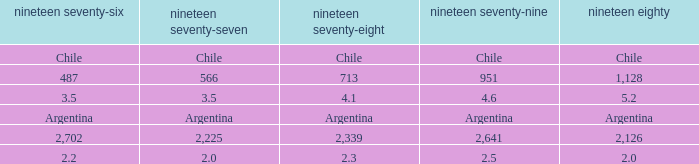What is 1976 when 1980 is 2.0? 2.2. 